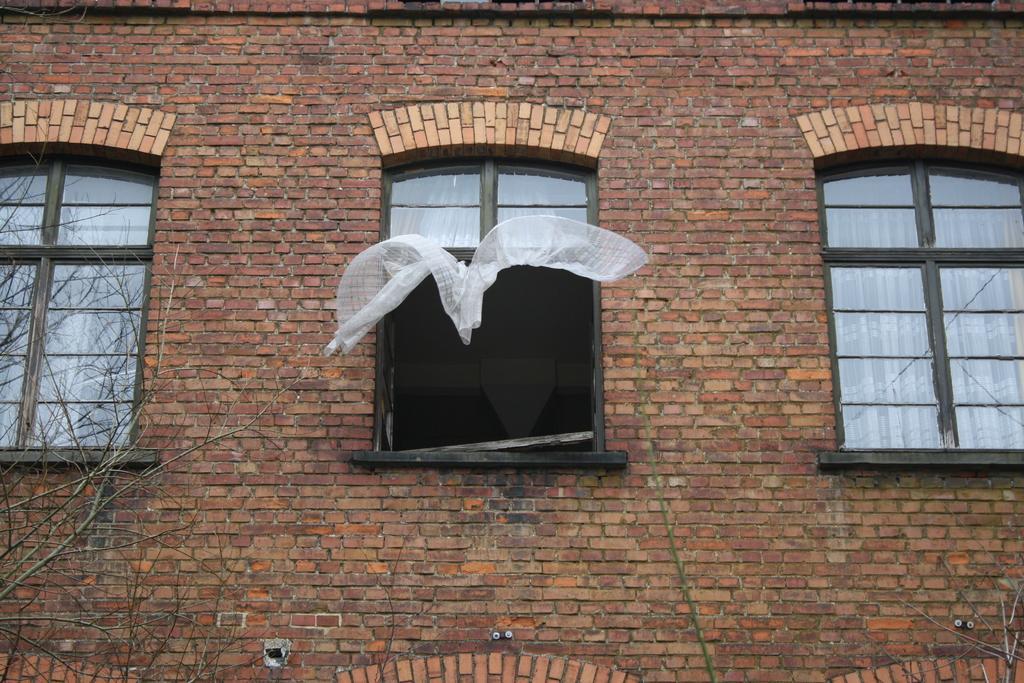Could you give a brief overview of what you see in this image? This image consists of a building along with windows. And we can see the curtains in white color. The wall is made up of bricks. 